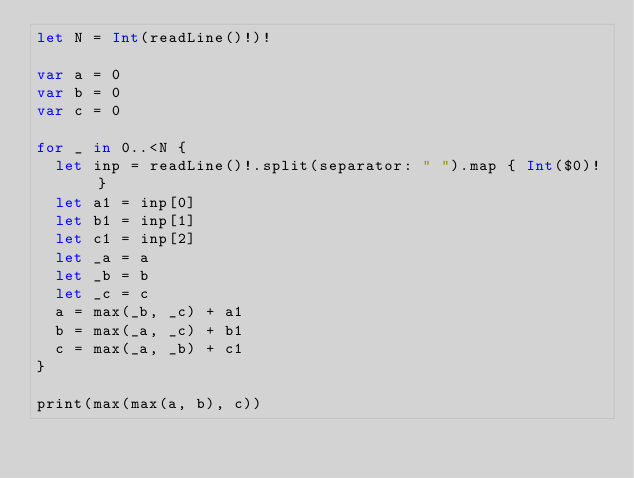<code> <loc_0><loc_0><loc_500><loc_500><_Swift_>let N = Int(readLine()!)!

var a = 0
var b = 0
var c = 0

for _ in 0..<N {
  let inp = readLine()!.split(separator: " ").map { Int($0)! }
  let a1 = inp[0]
  let b1 = inp[1]
  let c1 = inp[2]
  let _a = a
  let _b = b
  let _c = c
  a = max(_b, _c) + a1
  b = max(_a, _c) + b1
  c = max(_a, _b) + c1
}

print(max(max(a, b), c))</code> 